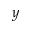<formula> <loc_0><loc_0><loc_500><loc_500>y</formula> 